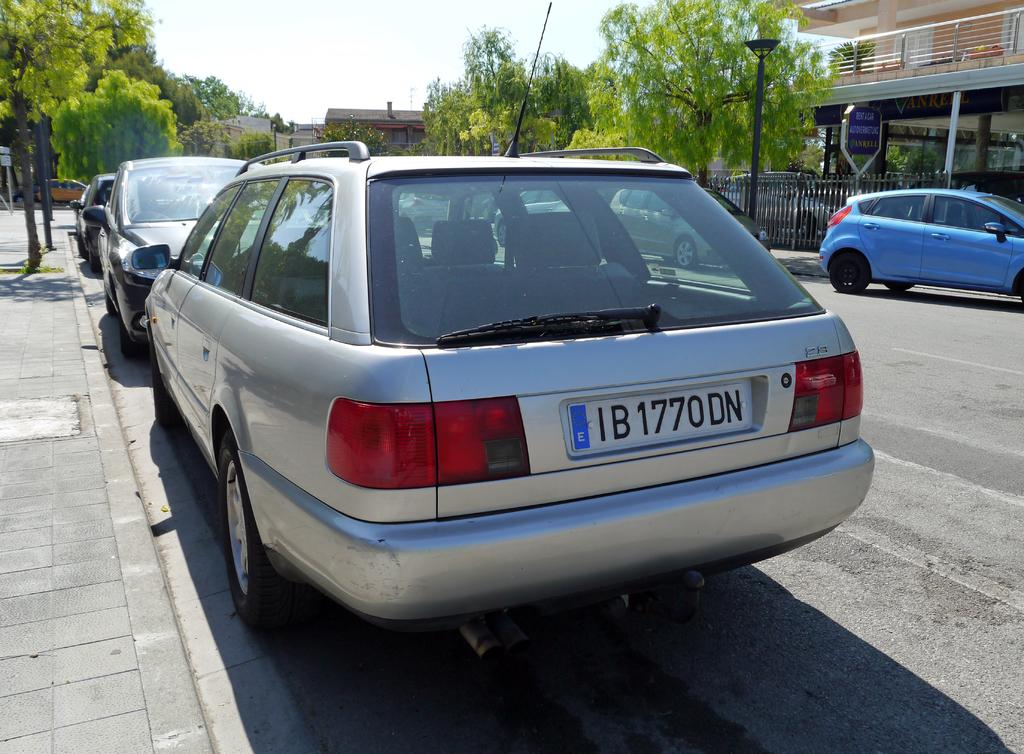Provide a one-sentence caption for the provided image. A parked silver car has a license plate that reads IB1770DN. 